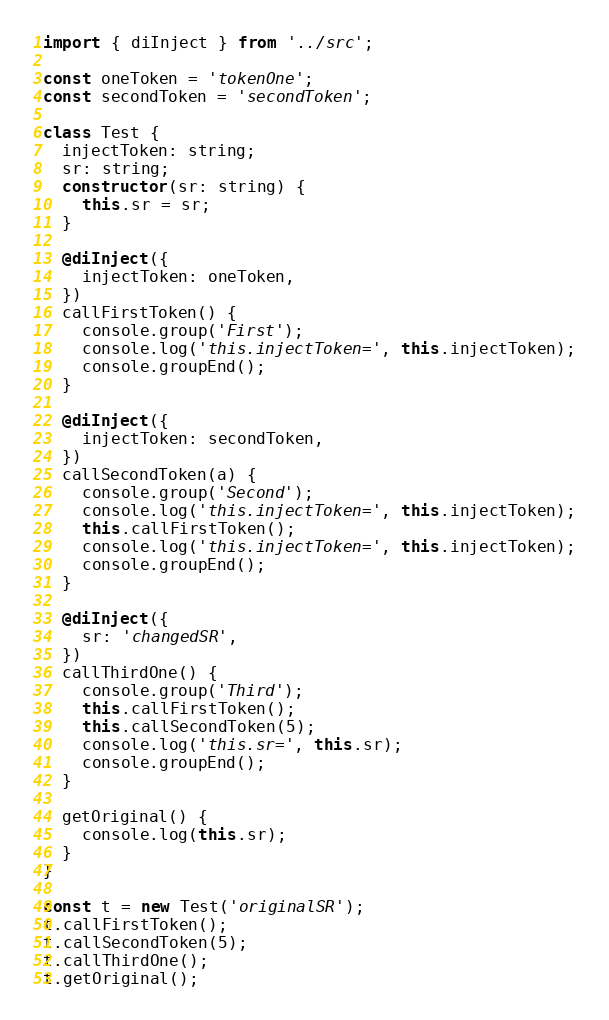<code> <loc_0><loc_0><loc_500><loc_500><_TypeScript_>import { diInject } from '../src';

const oneToken = 'tokenOne';
const secondToken = 'secondToken';

class Test {
  injectToken: string;
  sr: string;
  constructor(sr: string) {
    this.sr = sr;
  }

  @diInject({
    injectToken: oneToken,
  })
  callFirstToken() {
    console.group('First');
    console.log('this.injectToken=', this.injectToken);
    console.groupEnd();
  }

  @diInject({
    injectToken: secondToken,
  })
  callSecondToken(a) {
    console.group('Second');
    console.log('this.injectToken=', this.injectToken);
    this.callFirstToken();
    console.log('this.injectToken=', this.injectToken);
    console.groupEnd();
  }

  @diInject({
    sr: 'changedSR',
  })
  callThirdOne() {
    console.group('Third');
    this.callFirstToken();
    this.callSecondToken(5);
    console.log('this.sr=', this.sr);
    console.groupEnd();
  }

  getOriginal() {
    console.log(this.sr);
  }
}

const t = new Test('originalSR');
t.callFirstToken();
t.callSecondToken(5);
t.callThirdOne();
t.getOriginal();
</code> 